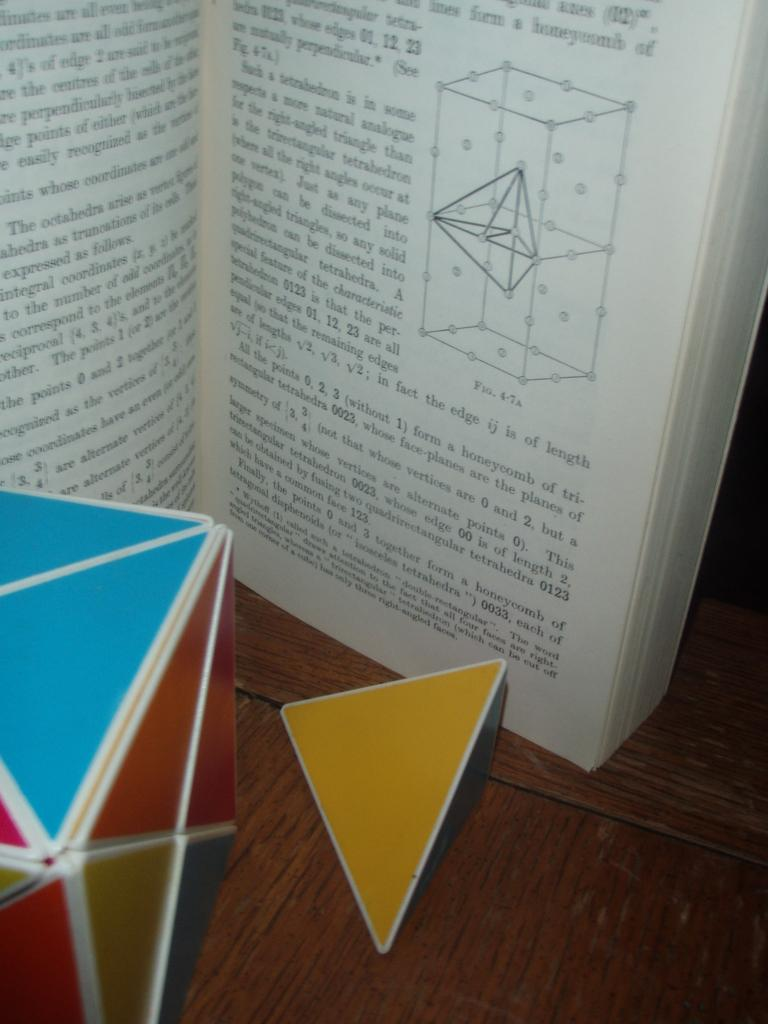What is the main object in the image? There is a book in the image. What is the surface made of that the other objects are on? The wooden surface in the image. Can you describe the book in the image? There is writing on the book. How many cars are parked next to the book in the image? There are no cars present in the image. Is there a guitar leaning against the book in the image? There is no guitar present in the image. 